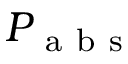Convert formula to latex. <formula><loc_0><loc_0><loc_500><loc_500>P _ { a b s }</formula> 